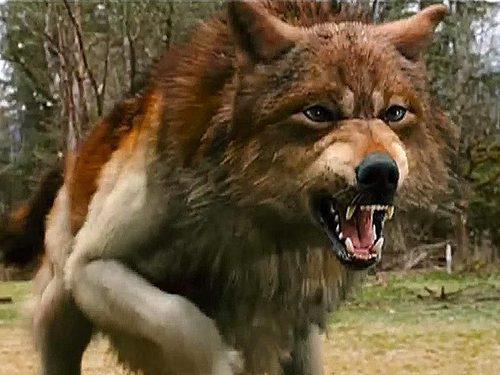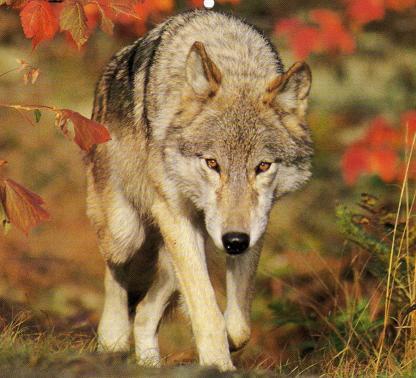The first image is the image on the left, the second image is the image on the right. For the images displayed, is the sentence "All of the images show a wolf in a standing position." factually correct? Answer yes or no. Yes. The first image is the image on the left, the second image is the image on the right. Analyze the images presented: Is the assertion "In the image of the wolf on the right, it appears to be autumn." valid? Answer yes or no. Yes. 